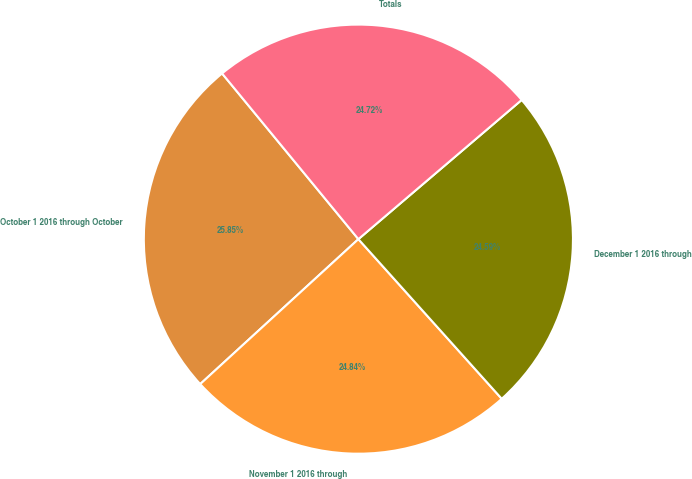Convert chart to OTSL. <chart><loc_0><loc_0><loc_500><loc_500><pie_chart><fcel>October 1 2016 through October<fcel>November 1 2016 through<fcel>December 1 2016 through<fcel>Totals<nl><fcel>25.85%<fcel>24.84%<fcel>24.59%<fcel>24.72%<nl></chart> 